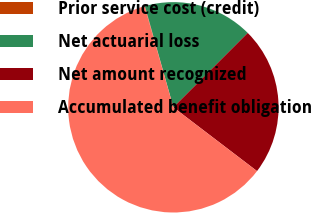<chart> <loc_0><loc_0><loc_500><loc_500><pie_chart><fcel>Prior service cost (credit)<fcel>Net actuarial loss<fcel>Net amount recognized<fcel>Accumulated benefit obligation<nl><fcel>0.06%<fcel>16.86%<fcel>22.87%<fcel>60.21%<nl></chart> 